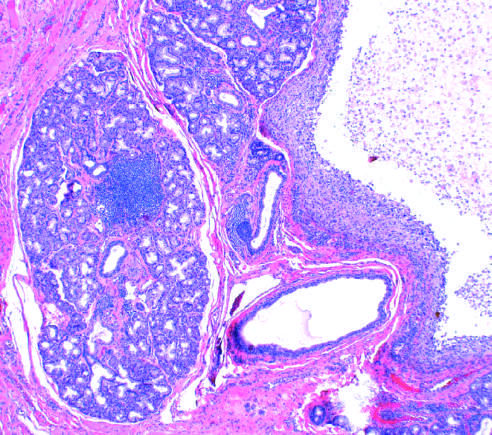re the normal gland acini seen on the left?
Answer the question using a single word or phrase. Yes 